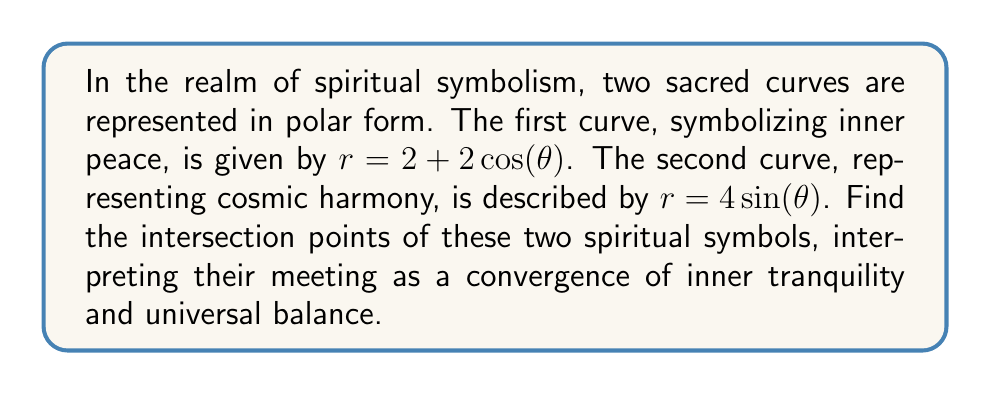Can you solve this math problem? To find the intersection points of these two curves, we need to solve the equation where both $r$ values are equal:

$$2 + 2\cos(\theta) = 4\sin(\theta)$$

Let's solve this step-by-step:

1) First, rearrange the equation:
   $$2\cos(\theta) - 4\sin(\theta) = -2$$

2) Divide both sides by 2:
   $$\cos(\theta) - 2\sin(\theta) = -1$$

3) This is in the form $a\cos(\theta) + b\sin(\theta) = c$. We can solve this using the substitution method:
   Let $R = \sqrt{a^2 + b^2} = \sqrt{1^2 + (-2)^2} = \sqrt{5}$
   Let $\cos(\alpha) = \frac{a}{R} = \frac{1}{\sqrt{5}}$ and $\sin(\alpha) = \frac{-b}{R} = \frac{2}{\sqrt{5}}$

4) Substituting:
   $$R\cos(\alpha)\cos(\theta) + R\sin(\alpha)\sin(\theta) = -1$$
   $$\sqrt{5}[\cos(\alpha)\cos(\theta) + \sin(\alpha)\sin(\theta)] = -1$$
   $$\sqrt{5}\cos(\theta - \alpha) = -1$$

5) Solving for $\theta - \alpha$:
   $$\cos(\theta - \alpha) = -\frac{1}{\sqrt{5}}$$
   $$\theta - \alpha = \arccos(-\frac{1}{\sqrt{5}}) \text{ or } 2\pi - \arccos(-\frac{1}{\sqrt{5}})$$

6) Since $\alpha = \arctan(2)$, we can find $\theta$:
   $$\theta = \arccos(-\frac{1}{\sqrt{5}}) + \arctan(2) \text{ or } 2\pi - \arccos(-\frac{1}{\sqrt{5}}) + \arctan(2)$$

7) Calculate the values:
   $$\theta \approx 2.498 \text{ or } 3.785$$

8) To find $r$, substitute either $\theta$ value into one of the original equations:
   $$r = 2 + 2\cos(2.498) \approx 1.382 \text{ or } r = 2 + 2\cos(3.785) \approx 3.618$$

Therefore, the intersection points in polar coordinates are approximately $(1.382, 2.498)$ and $(3.618, 3.785)$.
Answer: The spiritual symbols intersect at approximately $(1.382, 2.498)$ and $(3.618, 3.785)$ in polar coordinates $(r, \theta)$. 